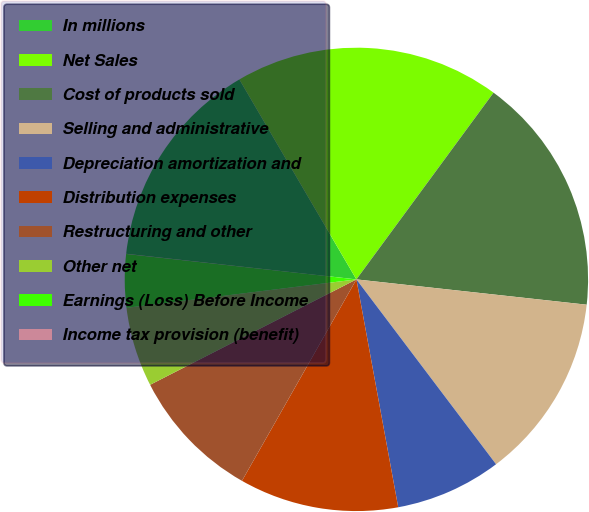Convert chart. <chart><loc_0><loc_0><loc_500><loc_500><pie_chart><fcel>In millions<fcel>Net Sales<fcel>Cost of products sold<fcel>Selling and administrative<fcel>Depreciation amortization and<fcel>Distribution expenses<fcel>Restructuring and other<fcel>Other net<fcel>Earnings (Loss) Before Income<fcel>Income tax provision (benefit)<nl><fcel>14.81%<fcel>18.51%<fcel>16.66%<fcel>12.96%<fcel>7.41%<fcel>11.11%<fcel>9.26%<fcel>5.56%<fcel>3.71%<fcel>0.01%<nl></chart> 